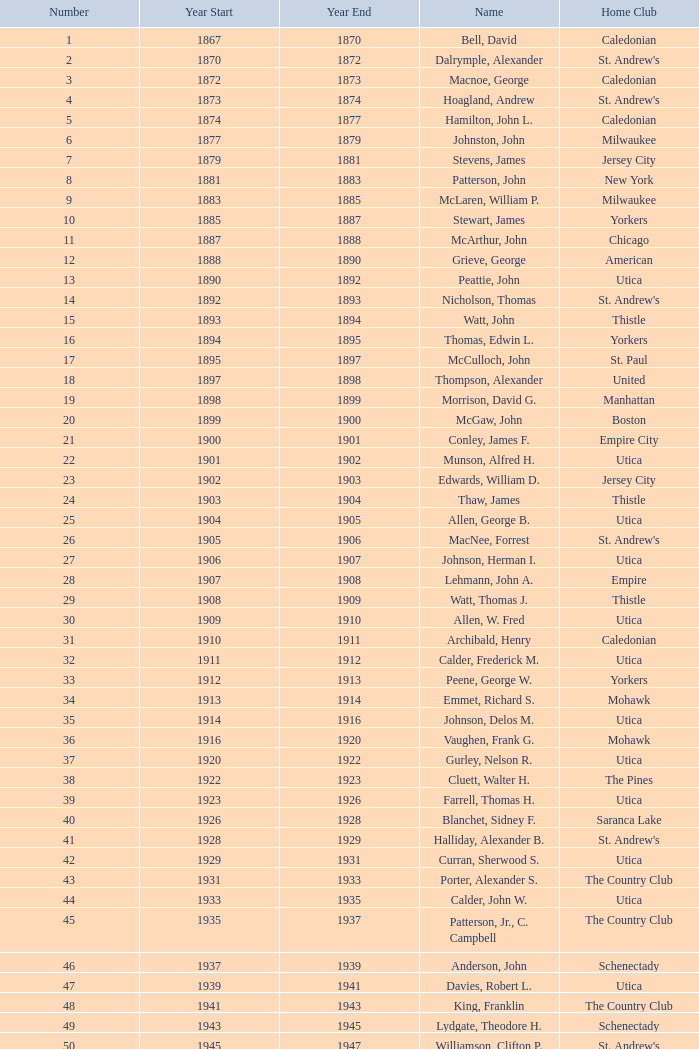Which year has a starting figure of 28? 1907.0. 